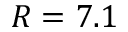<formula> <loc_0><loc_0><loc_500><loc_500>R = 7 . 1</formula> 